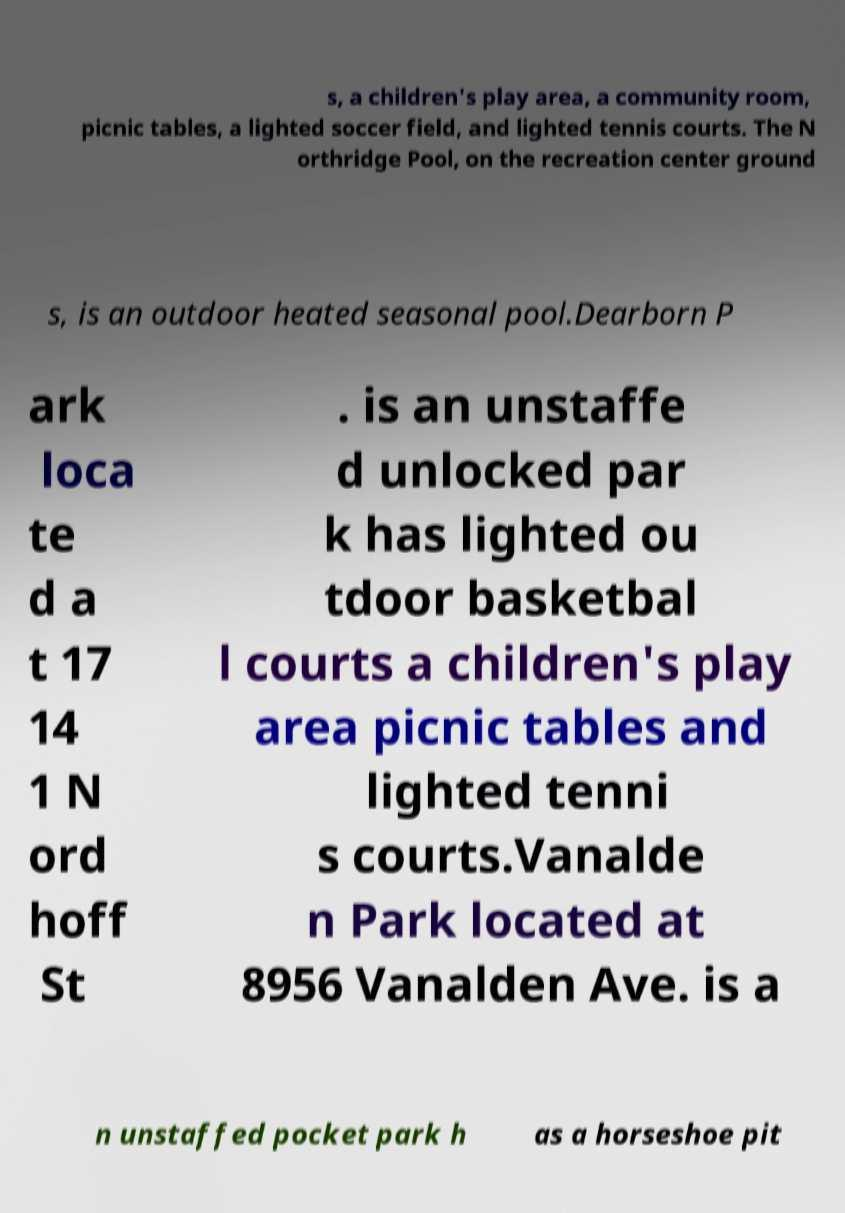Can you read and provide the text displayed in the image?This photo seems to have some interesting text. Can you extract and type it out for me? s, a children's play area, a community room, picnic tables, a lighted soccer field, and lighted tennis courts. The N orthridge Pool, on the recreation center ground s, is an outdoor heated seasonal pool.Dearborn P ark loca te d a t 17 14 1 N ord hoff St . is an unstaffe d unlocked par k has lighted ou tdoor basketbal l courts a children's play area picnic tables and lighted tenni s courts.Vanalde n Park located at 8956 Vanalden Ave. is a n unstaffed pocket park h as a horseshoe pit 